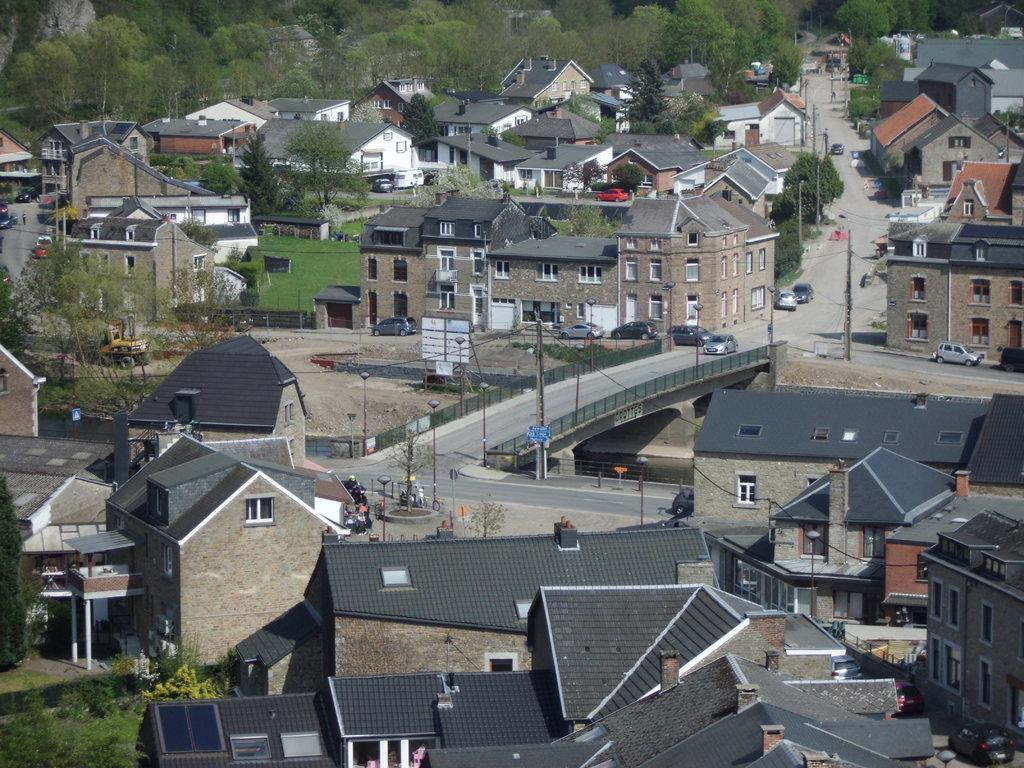What type of structures can be seen in the image? A: There are buildings in the image. What mode of transportation is visible on the road in the image? There are cars on the road in the image. What are the vertical structures in the image that support wires or signs? There are poles in the image. What type of vegetation is present in the image? There are trees in the image. What type of ground cover can be seen in the bottom left of the image? There is grass on the ground in the bottom left of the image. Can you tell me how the stranger is adjusting the fuel in the image? There is no stranger or fuel present in the image. What type of adjustment is being made to the trees in the image? There is no adjustment being made to the trees in the image; they are simply standing as part of the landscape. 